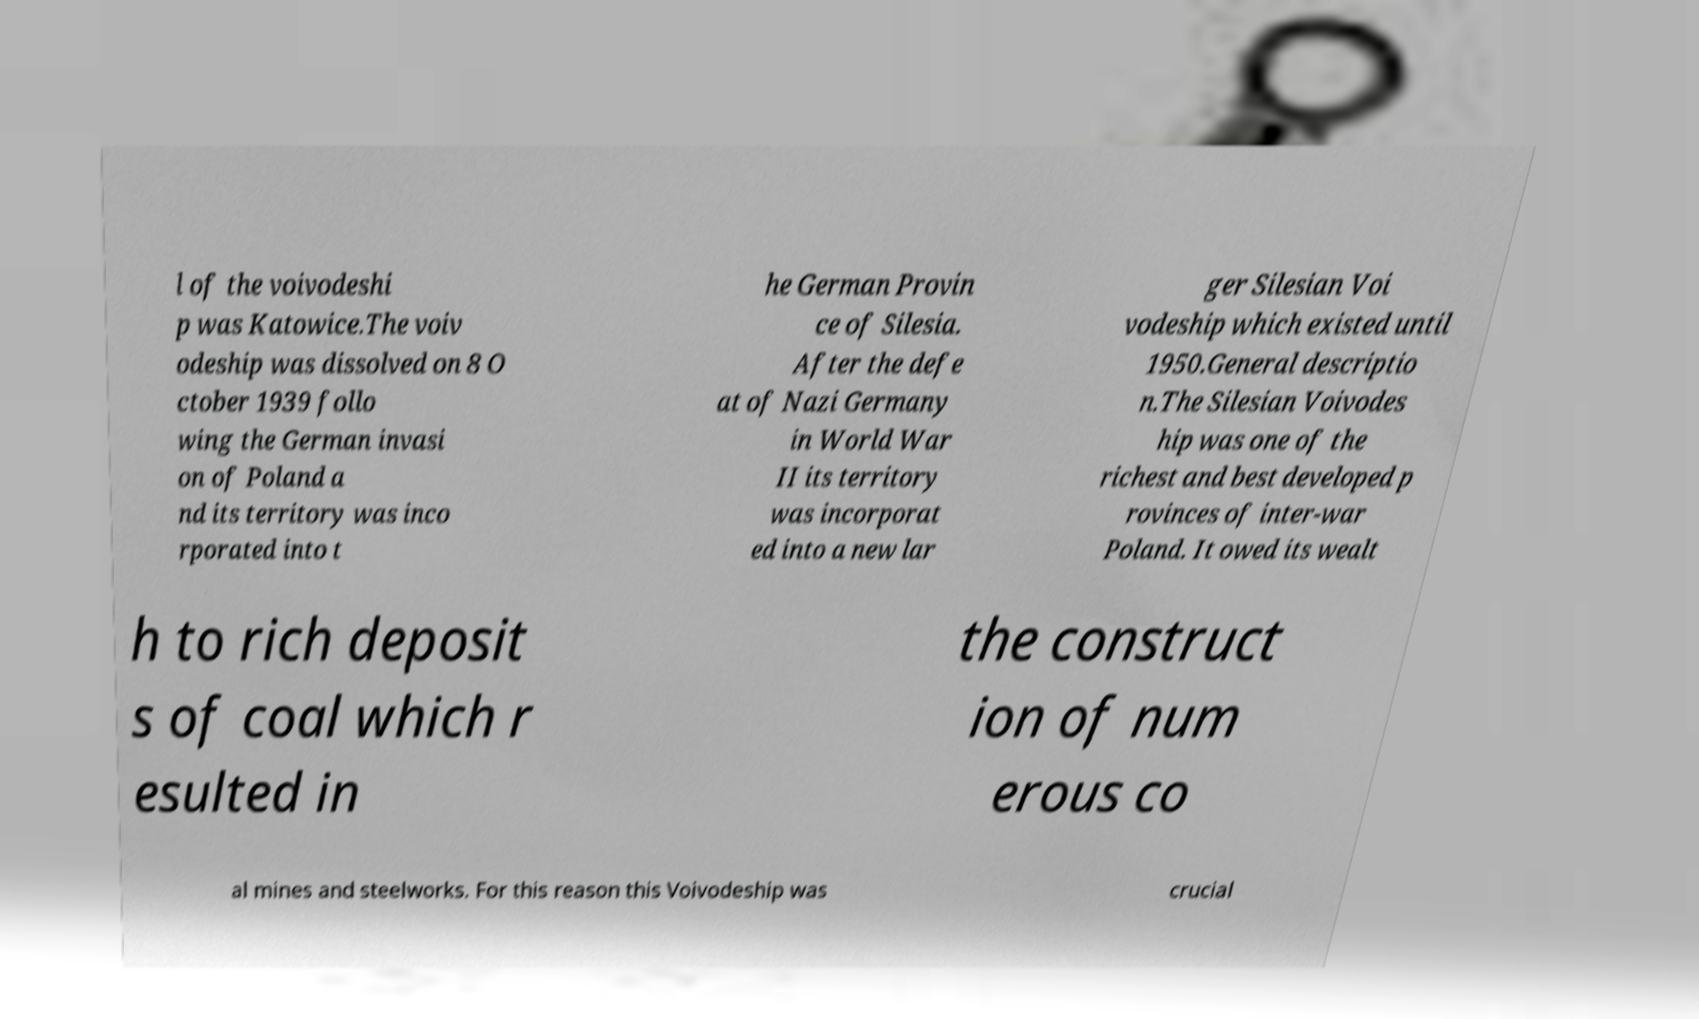Can you read and provide the text displayed in the image?This photo seems to have some interesting text. Can you extract and type it out for me? l of the voivodeshi p was Katowice.The voiv odeship was dissolved on 8 O ctober 1939 follo wing the German invasi on of Poland a nd its territory was inco rporated into t he German Provin ce of Silesia. After the defe at of Nazi Germany in World War II its territory was incorporat ed into a new lar ger Silesian Voi vodeship which existed until 1950.General descriptio n.The Silesian Voivodes hip was one of the richest and best developed p rovinces of inter-war Poland. It owed its wealt h to rich deposit s of coal which r esulted in the construct ion of num erous co al mines and steelworks. For this reason this Voivodeship was crucial 